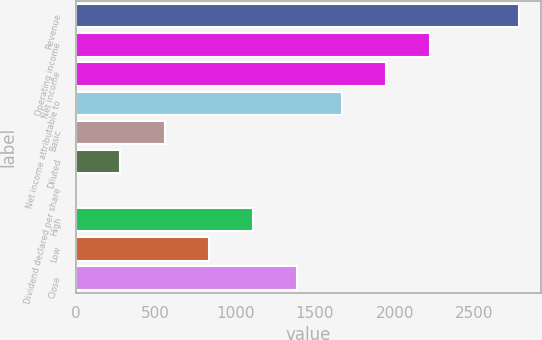<chart> <loc_0><loc_0><loc_500><loc_500><bar_chart><fcel>Revenue<fcel>Operating income<fcel>Net income<fcel>Net income attributable to<fcel>Basic<fcel>Diluted<fcel>Dividend declared per share<fcel>High<fcel>Low<fcel>Close<nl><fcel>2777<fcel>2221.92<fcel>1944.39<fcel>1666.86<fcel>556.74<fcel>279.21<fcel>1.68<fcel>1111.8<fcel>834.27<fcel>1389.33<nl></chart> 